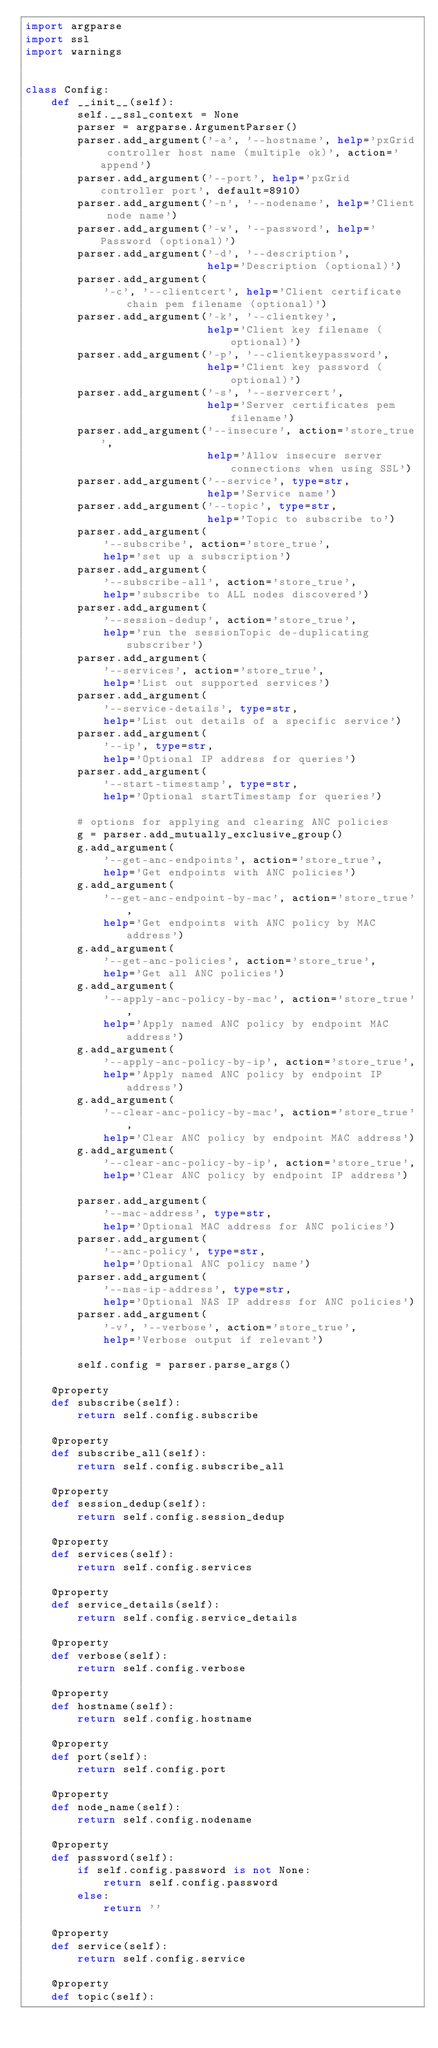<code> <loc_0><loc_0><loc_500><loc_500><_Python_>import argparse
import ssl
import warnings


class Config:
    def __init__(self):
        self.__ssl_context = None
        parser = argparse.ArgumentParser()
        parser.add_argument('-a', '--hostname', help='pxGrid controller host name (multiple ok)', action='append')
        parser.add_argument('--port', help='pxGrid controller port', default=8910)
        parser.add_argument('-n', '--nodename', help='Client node name')
        parser.add_argument('-w', '--password', help='Password (optional)')
        parser.add_argument('-d', '--description',
                            help='Description (optional)')
        parser.add_argument(
            '-c', '--clientcert', help='Client certificate chain pem filename (optional)')
        parser.add_argument('-k', '--clientkey',
                            help='Client key filename (optional)')
        parser.add_argument('-p', '--clientkeypassword',
                            help='Client key password (optional)')
        parser.add_argument('-s', '--servercert',
                            help='Server certificates pem filename')
        parser.add_argument('--insecure', action='store_true',
                            help='Allow insecure server connections when using SSL')
        parser.add_argument('--service', type=str,
                            help='Service name')
        parser.add_argument('--topic', type=str,
                            help='Topic to subscribe to')
        parser.add_argument(
            '--subscribe', action='store_true',
            help='set up a subscription')
        parser.add_argument(
            '--subscribe-all', action='store_true',
            help='subscribe to ALL nodes discovered')
        parser.add_argument(
            '--session-dedup', action='store_true',
            help='run the sessionTopic de-duplicating subscriber')
        parser.add_argument(
            '--services', action='store_true',
            help='List out supported services')
        parser.add_argument(
            '--service-details', type=str,
            help='List out details of a specific service')
        parser.add_argument(
            '--ip', type=str,
            help='Optional IP address for queries')
        parser.add_argument(
            '--start-timestamp', type=str,
            help='Optional startTimestamp for queries')

        # options for applying and clearing ANC policies
        g = parser.add_mutually_exclusive_group()
        g.add_argument(
            '--get-anc-endpoints', action='store_true',
            help='Get endpoints with ANC policies')
        g.add_argument(
            '--get-anc-endpoint-by-mac', action='store_true',
            help='Get endpoints with ANC policy by MAC address')
        g.add_argument(
            '--get-anc-policies', action='store_true',
            help='Get all ANC policies')
        g.add_argument(
            '--apply-anc-policy-by-mac', action='store_true',
            help='Apply named ANC policy by endpoint MAC address')
        g.add_argument(
            '--apply-anc-policy-by-ip', action='store_true',
            help='Apply named ANC policy by endpoint IP address')
        g.add_argument(
            '--clear-anc-policy-by-mac', action='store_true',
            help='Clear ANC policy by endpoint MAC address')
        g.add_argument(
            '--clear-anc-policy-by-ip', action='store_true',
            help='Clear ANC policy by endpoint IP address')
        
        parser.add_argument(
            '--mac-address', type=str,
            help='Optional MAC address for ANC policies')
        parser.add_argument(
            '--anc-policy', type=str,
            help='Optional ANC policy name')
        parser.add_argument(
            '--nas-ip-address', type=str,
            help='Optional NAS IP address for ANC policies')
        parser.add_argument(
            '-v', '--verbose', action='store_true',
            help='Verbose output if relevant')

        self.config = parser.parse_args()

    @property
    def subscribe(self):
        return self.config.subscribe

    @property
    def subscribe_all(self):
        return self.config.subscribe_all

    @property
    def session_dedup(self):
        return self.config.session_dedup

    @property
    def services(self):
        return self.config.services

    @property
    def service_details(self):
        return self.config.service_details

    @property
    def verbose(self):
        return self.config.verbose

    @property
    def hostname(self):
        return self.config.hostname

    @property
    def port(self):
        return self.config.port

    @property
    def node_name(self):
        return self.config.nodename

    @property
    def password(self):
        if self.config.password is not None:
            return self.config.password
        else:
            return ''

    @property
    def service(self):
        return self.config.service

    @property
    def topic(self):</code> 